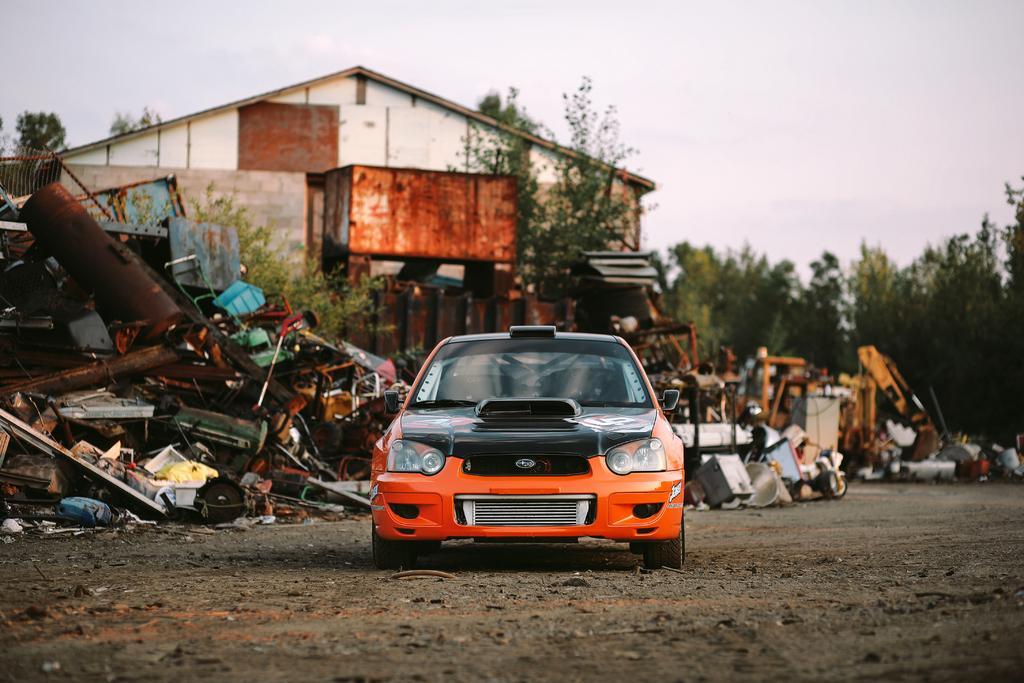Please provide a concise description of this image. In the center of the image there is a orange color car. In the background of the image there is a house. There are trees. At the bottom of the image there is ground. At the top of the image there is sky. 